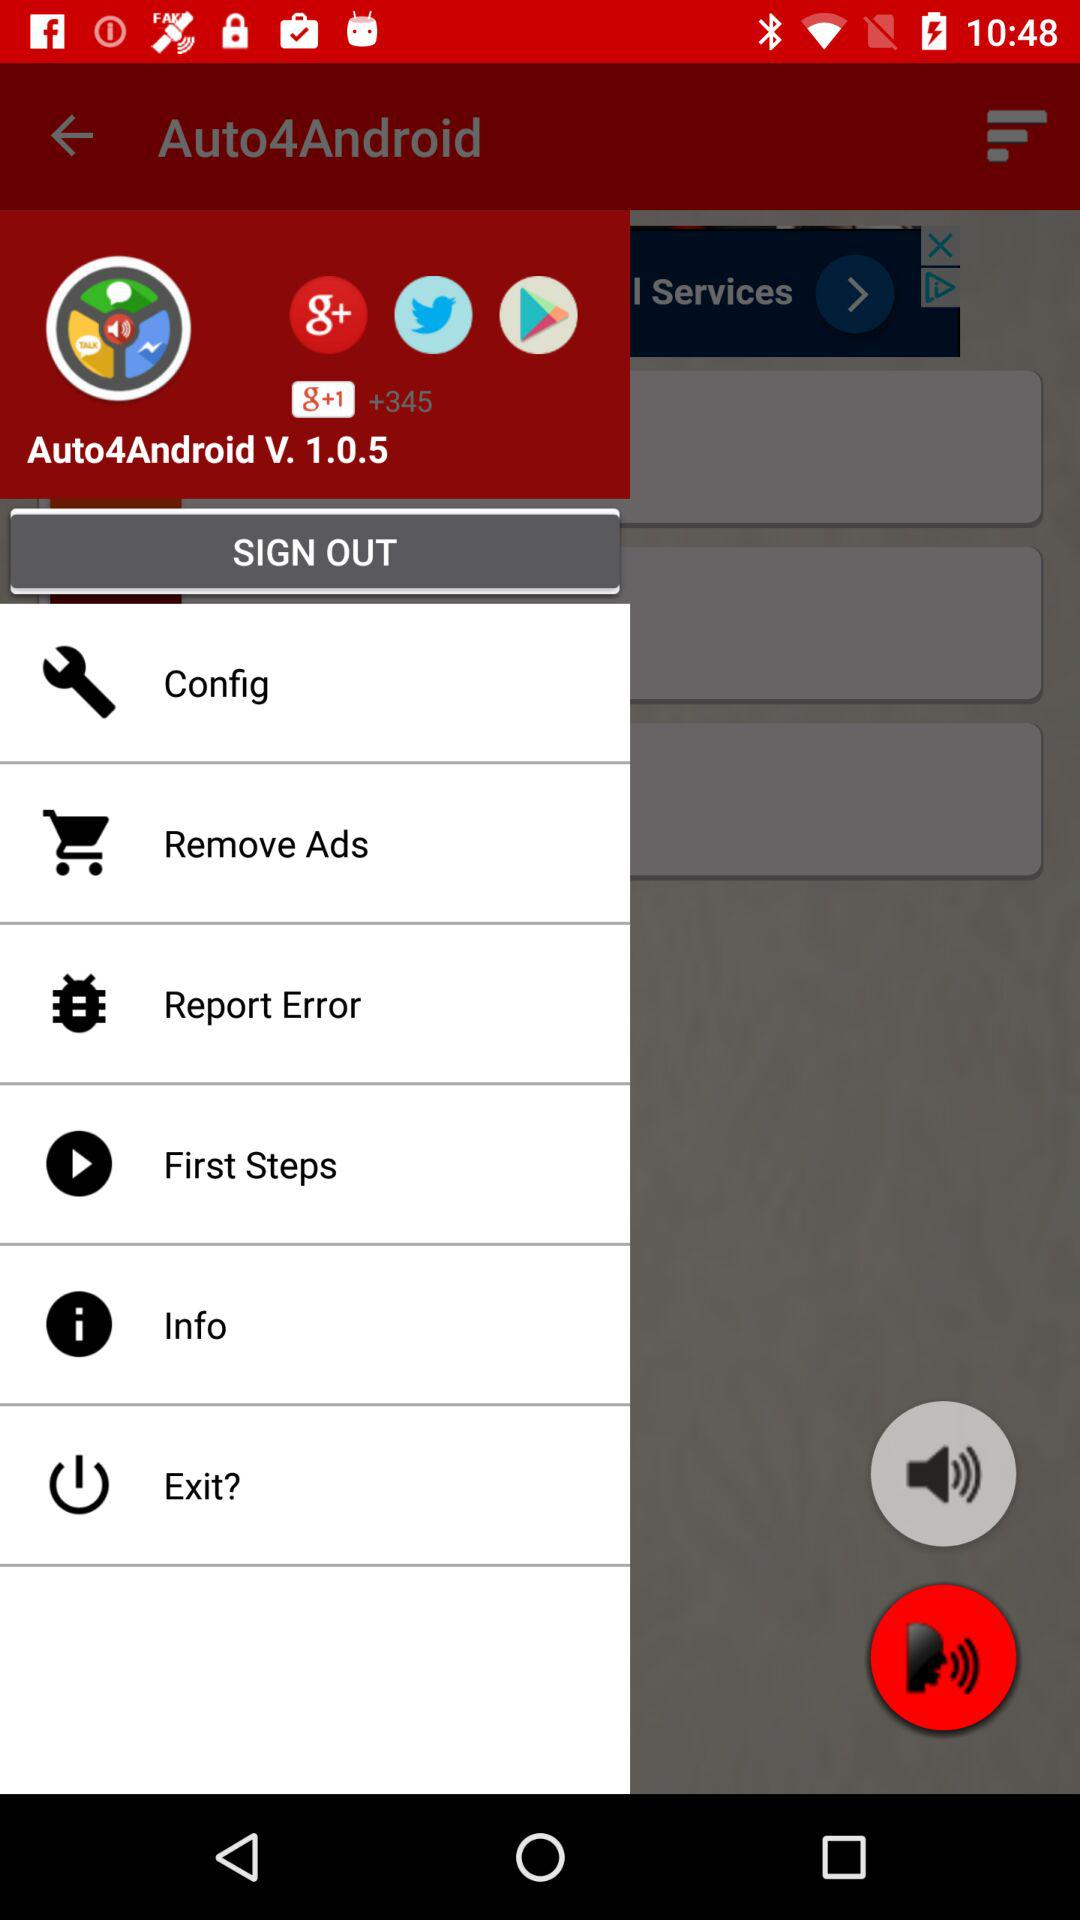What is the version of "Auto4Android"? The version of "Auto4Android" is V. 1.0.5. 